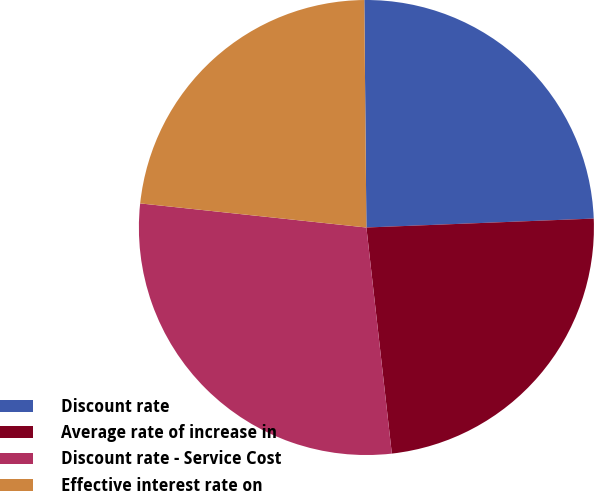Convert chart to OTSL. <chart><loc_0><loc_0><loc_500><loc_500><pie_chart><fcel>Discount rate<fcel>Average rate of increase in<fcel>Discount rate - Service Cost<fcel>Effective interest rate on<nl><fcel>24.52%<fcel>23.84%<fcel>28.47%<fcel>23.16%<nl></chart> 